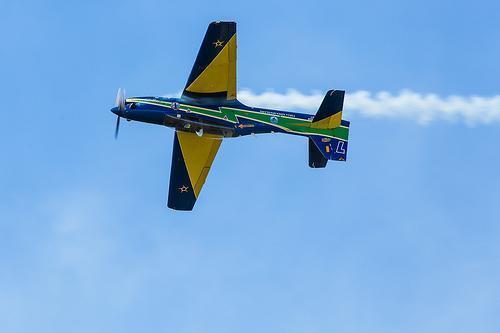How many planes are in the sky?
Give a very brief answer. 1. 